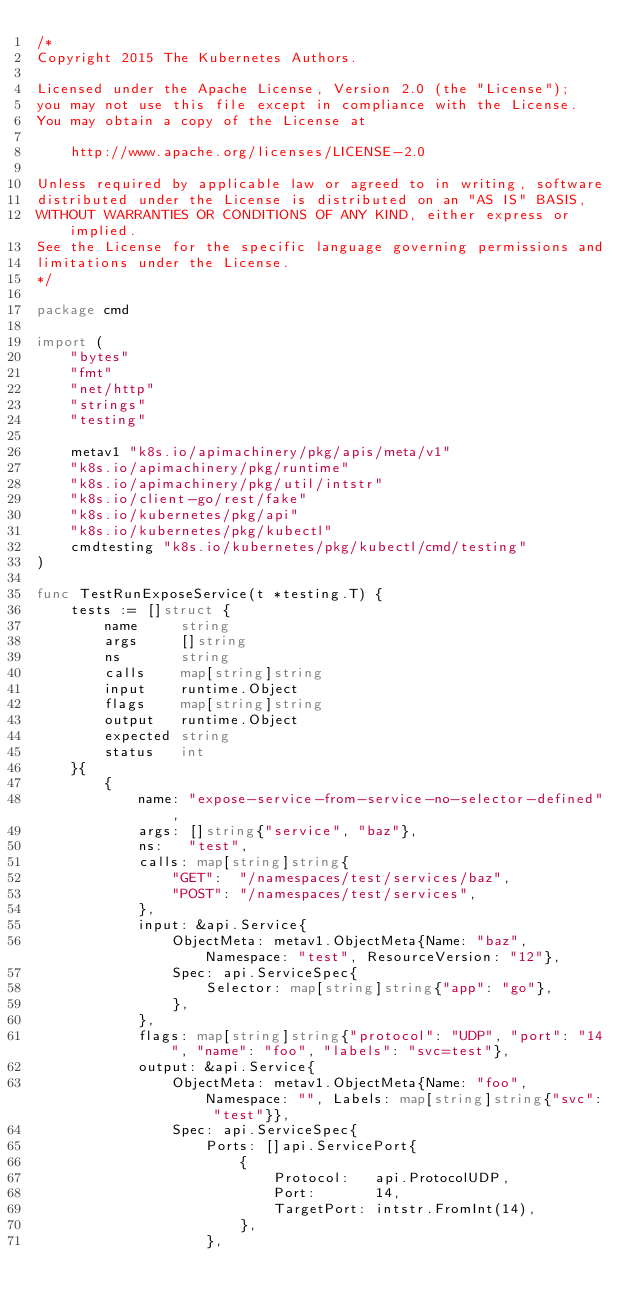Convert code to text. <code><loc_0><loc_0><loc_500><loc_500><_Go_>/*
Copyright 2015 The Kubernetes Authors.

Licensed under the Apache License, Version 2.0 (the "License");
you may not use this file except in compliance with the License.
You may obtain a copy of the License at

    http://www.apache.org/licenses/LICENSE-2.0

Unless required by applicable law or agreed to in writing, software
distributed under the License is distributed on an "AS IS" BASIS,
WITHOUT WARRANTIES OR CONDITIONS OF ANY KIND, either express or implied.
See the License for the specific language governing permissions and
limitations under the License.
*/

package cmd

import (
	"bytes"
	"fmt"
	"net/http"
	"strings"
	"testing"

	metav1 "k8s.io/apimachinery/pkg/apis/meta/v1"
	"k8s.io/apimachinery/pkg/runtime"
	"k8s.io/apimachinery/pkg/util/intstr"
	"k8s.io/client-go/rest/fake"
	"k8s.io/kubernetes/pkg/api"
	"k8s.io/kubernetes/pkg/kubectl"
	cmdtesting "k8s.io/kubernetes/pkg/kubectl/cmd/testing"
)

func TestRunExposeService(t *testing.T) {
	tests := []struct {
		name     string
		args     []string
		ns       string
		calls    map[string]string
		input    runtime.Object
		flags    map[string]string
		output   runtime.Object
		expected string
		status   int
	}{
		{
			name: "expose-service-from-service-no-selector-defined",
			args: []string{"service", "baz"},
			ns:   "test",
			calls: map[string]string{
				"GET":  "/namespaces/test/services/baz",
				"POST": "/namespaces/test/services",
			},
			input: &api.Service{
				ObjectMeta: metav1.ObjectMeta{Name: "baz", Namespace: "test", ResourceVersion: "12"},
				Spec: api.ServiceSpec{
					Selector: map[string]string{"app": "go"},
				},
			},
			flags: map[string]string{"protocol": "UDP", "port": "14", "name": "foo", "labels": "svc=test"},
			output: &api.Service{
				ObjectMeta: metav1.ObjectMeta{Name: "foo", Namespace: "", Labels: map[string]string{"svc": "test"}},
				Spec: api.ServiceSpec{
					Ports: []api.ServicePort{
						{
							Protocol:   api.ProtocolUDP,
							Port:       14,
							TargetPort: intstr.FromInt(14),
						},
					},</code> 